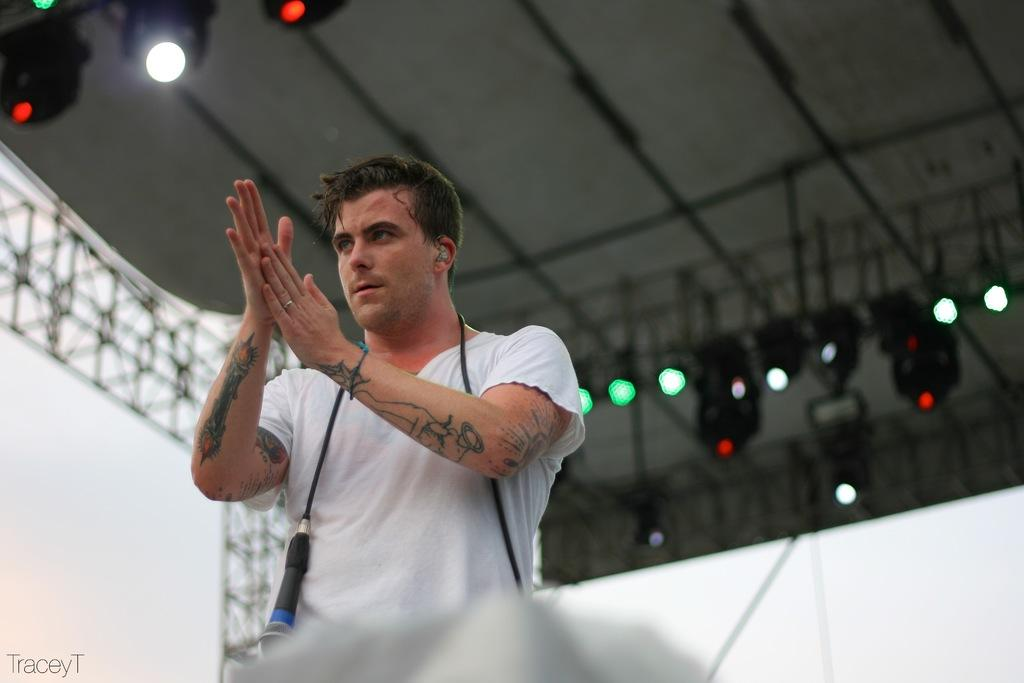Who is in the image? There is a person in the image. What is the person doing? The person is clapping. What can be seen in the background of the image? There are lights and a wall in the background of the image. How many rings are visible on the person's fingers in the image? There are no rings visible on the person's fingers in the image. What type of spiders can be seen crawling on the wall in the background? There are no spiders present in the image; only lights and a wall can be seen in the background. 